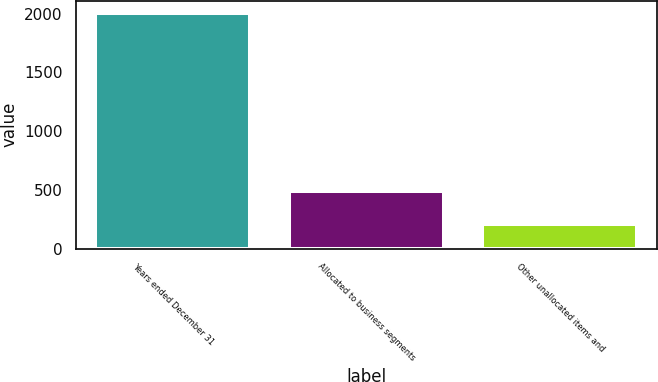<chart> <loc_0><loc_0><loc_500><loc_500><bar_chart><fcel>Years ended December 31<fcel>Allocated to business segments<fcel>Other unallocated items and<nl><fcel>2008<fcel>488<fcel>208<nl></chart> 